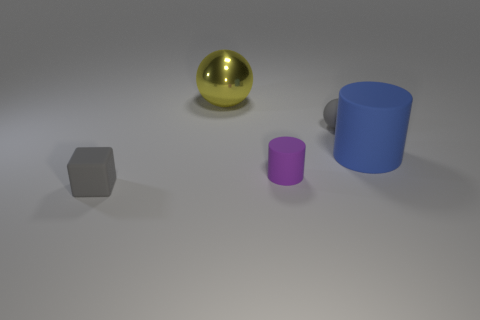Add 4 purple cylinders. How many objects exist? 9 Subtract all cylinders. How many objects are left? 3 Subtract all large rubber cylinders. Subtract all big yellow objects. How many objects are left? 3 Add 5 gray rubber things. How many gray rubber things are left? 7 Add 4 large cyan spheres. How many large cyan spheres exist? 4 Subtract 0 blue spheres. How many objects are left? 5 